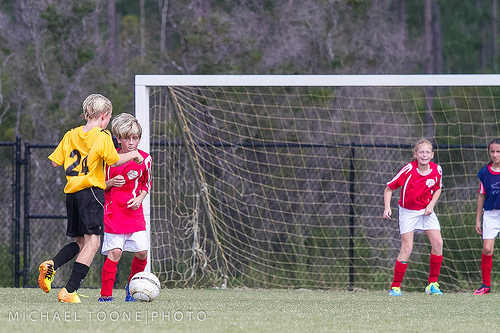<image>
Can you confirm if the ball is in front of the kid? Yes. The ball is positioned in front of the kid, appearing closer to the camera viewpoint. 